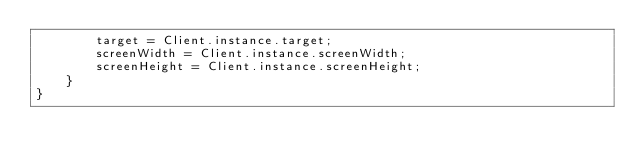<code> <loc_0><loc_0><loc_500><loc_500><_Haxe_>		target = Client.instance.target;
		screenWidth = Client.instance.screenWidth;
		screenHeight = Client.instance.screenHeight;
	}
}</code> 